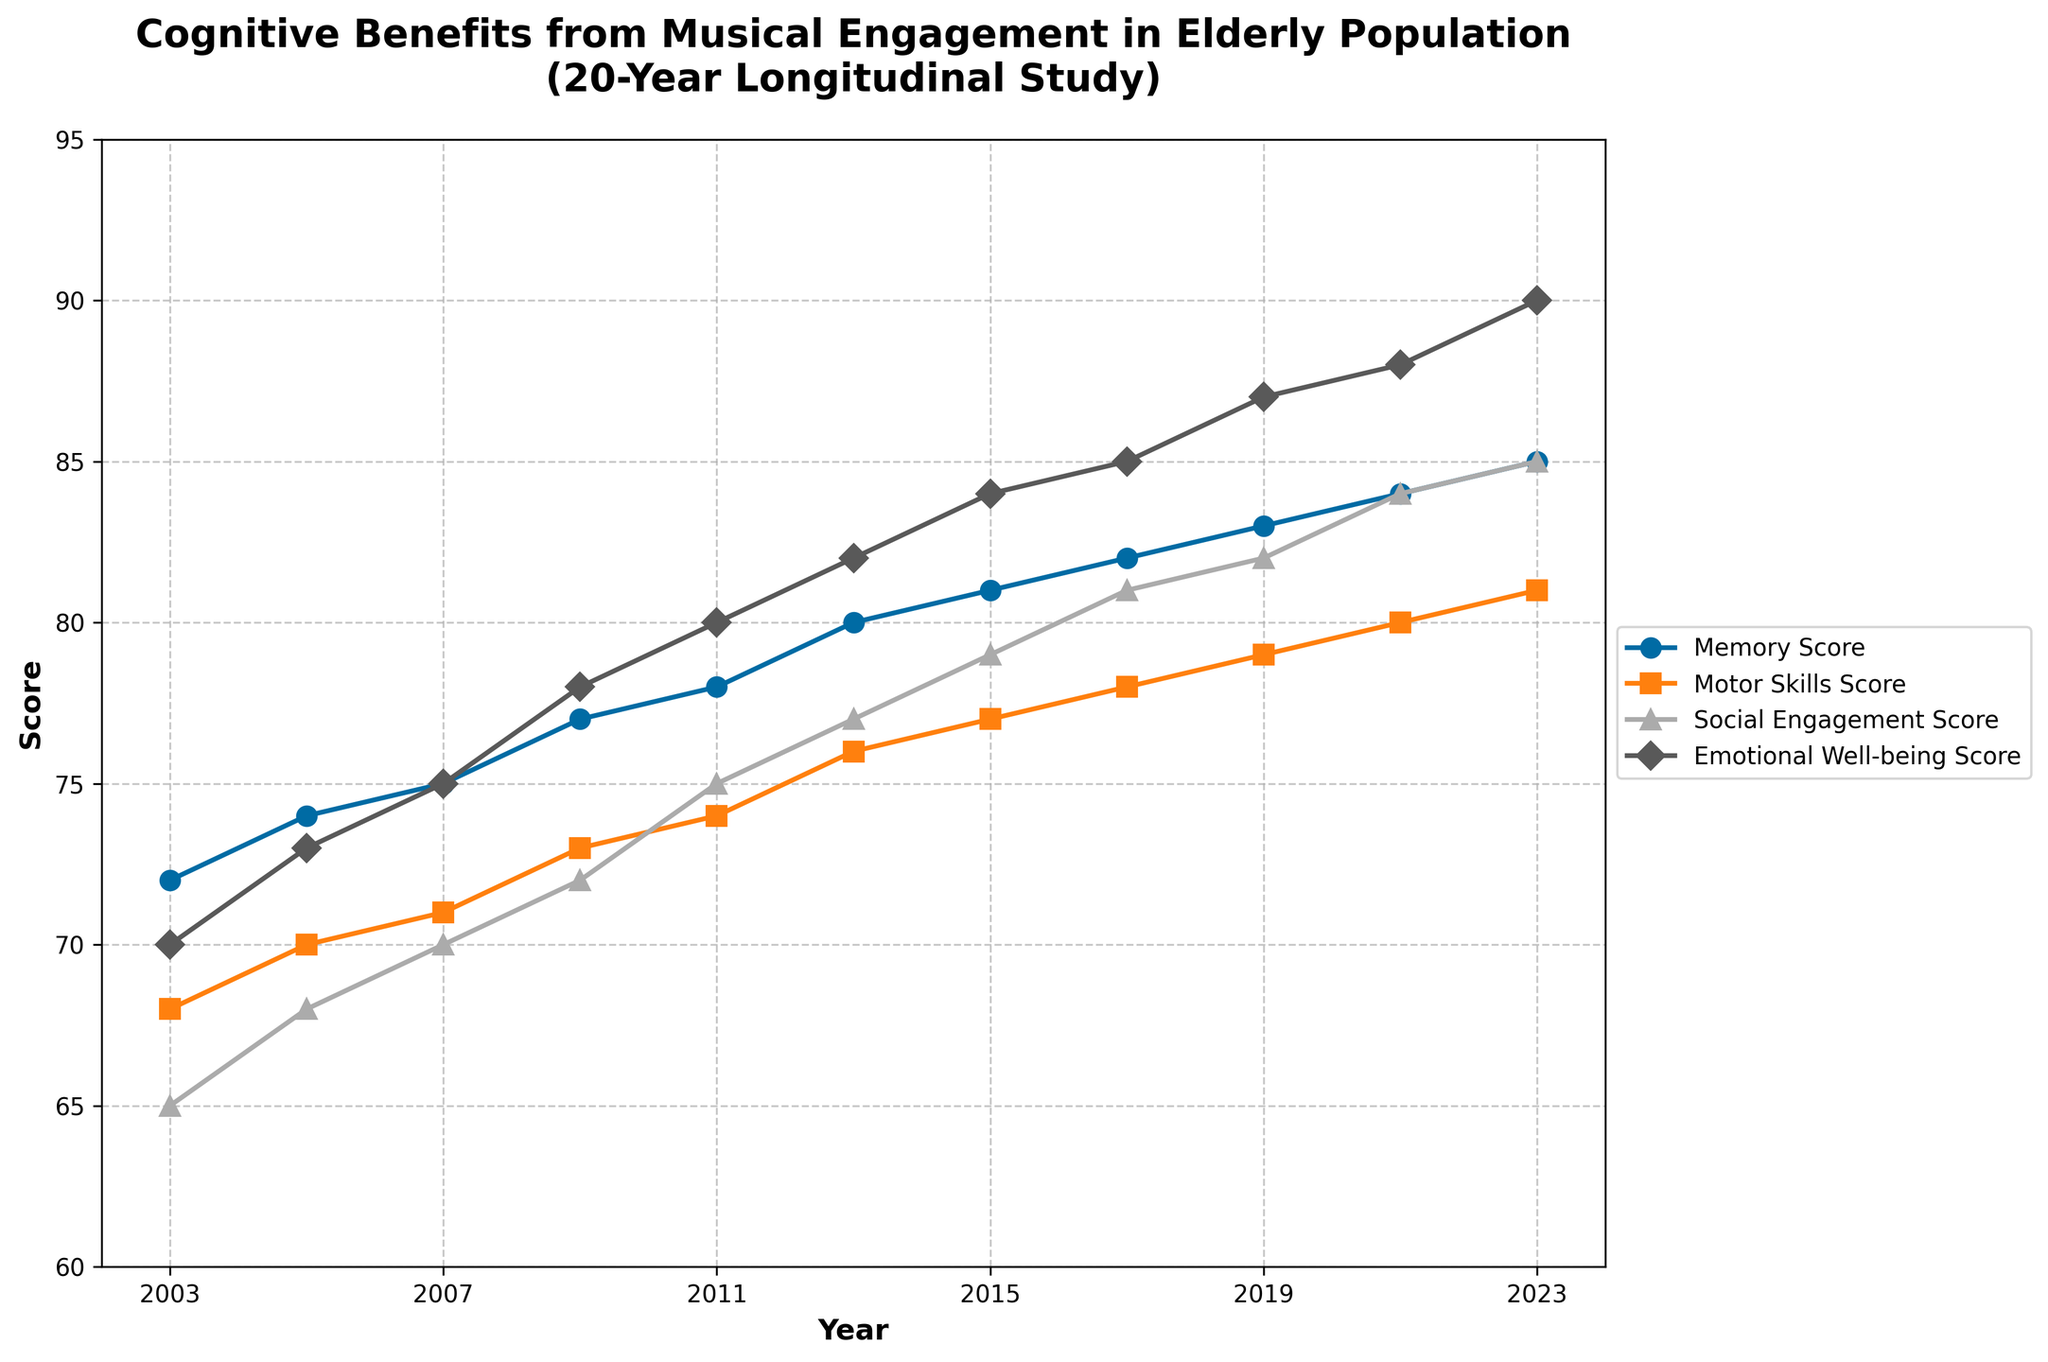What is the overall trend of the memory score from 2003 to 2023? To determine the overall trend of the memory score, observe the line representing the memory score data points from 2003 to 2023. The line generally ascends, showing a steady increase in memory scores over the 20-year period.
Answer: Increasing How much did the emotional well-being score increase from 2003 to 2023? The emotional well-being score in 2003 was 70, and it increased to 90 by 2023. The increase is calculated as 90 - 70.
Answer: 20 Which year saw the highest score for social engagement? By inspecting the line for social engagement score across the years, the highest value is noted in the year 2023, where the score reaches 85.
Answer: 2023 In which year did the motor skills score surpass 75? To determine the first year the motor skills score surpassed 75, look at the data points for motor skills. The score reaches 76 in 2013, which is above 75.
Answer: 2013 How do the memory score and motor skills score in 2011 compare? To compare these scores in 2011, check the values: memory score is 78, and motor skills score is 74. Memory score is higher.
Answer: Memory score is higher What is the difference between social engagement score and emotional well-being score in 2017? In 2017, the social engagement score is 81 and the emotional well-being score is 85. The difference is calculated as 85 - 81.
Answer: 4 Identify the year with the smallest gap between memory score and motor skills score. To find the smallest gap, calculate the difference between memory score and motor skills score for each year. The smallest gap is in 2007 (75 - 71 = 4).
Answer: 2007 What's the average score of memory across all years? Sum all memory scores from 2003 to 2023 (72+74+75+77+78+80+81+82+83+84+85=871) and divide by the number of years (11).
Answer: 79.18 Is there any year where all scores (memory, motor skills, social engagement, emotional well-being) increased compared to the previous year? Visually inspect the plot to confirm if all scores increased from the previous year. In 2019, all scores (memory, motor skills, social engagement, emotional well-being) increased compared to 2017.
Answer: Yes How does the growth trend of emotional well-being score compare to motor skills score over the 20-year period? Look at the respective lines for emotional well-being and motor skills over the 20 years. The emotional well-being score shows a steeper and more consistent upward trend compared to motor skills.
Answer: Emotional well-being score grows faster 